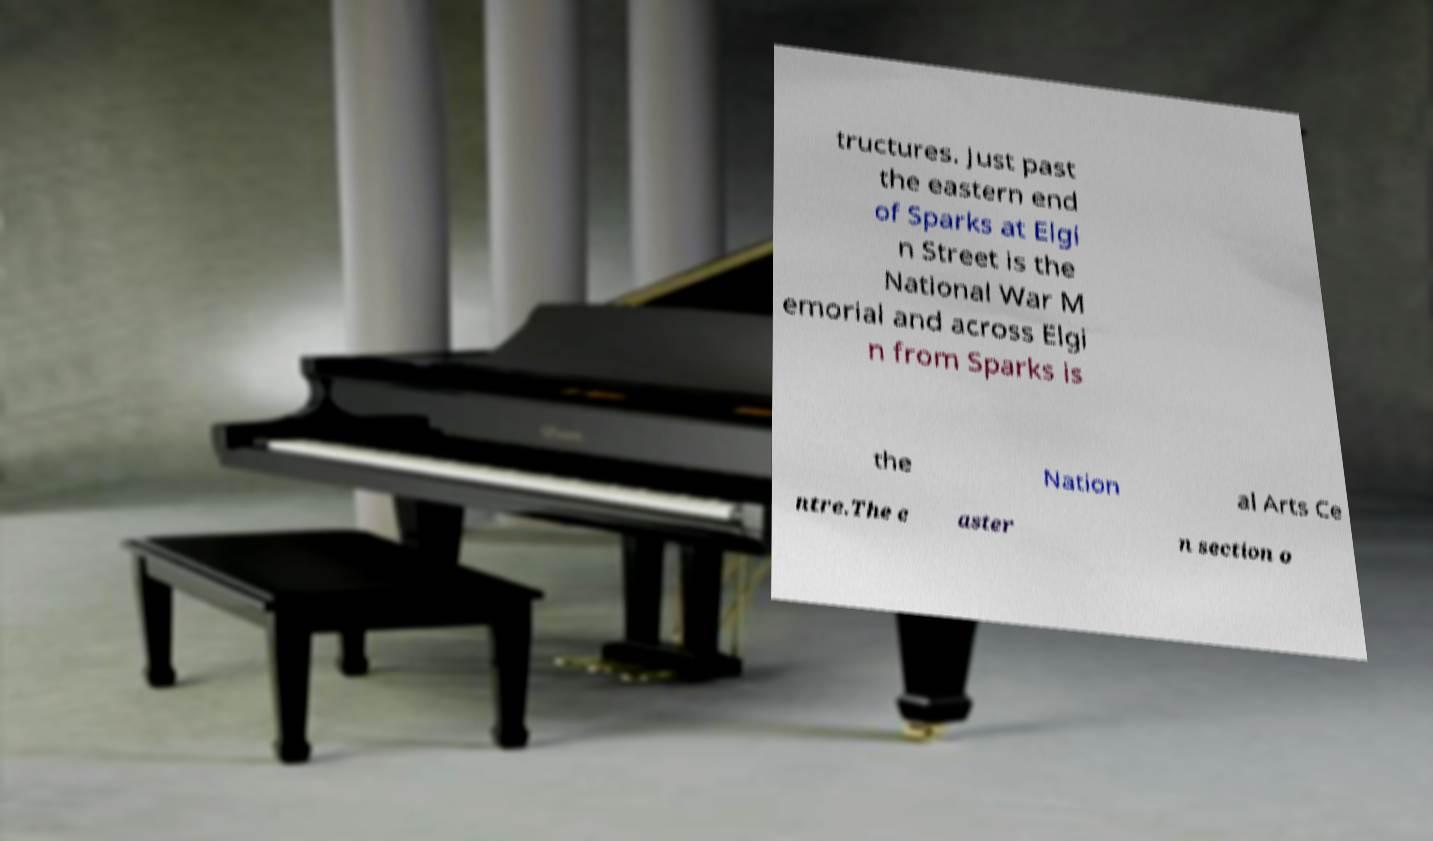For documentation purposes, I need the text within this image transcribed. Could you provide that? tructures. Just past the eastern end of Sparks at Elgi n Street is the National War M emorial and across Elgi n from Sparks is the Nation al Arts Ce ntre.The e aster n section o 